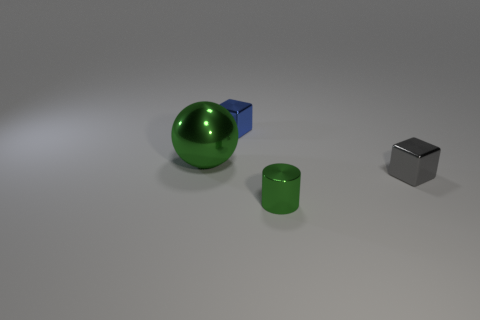Add 3 balls. How many objects exist? 7 Subtract all cylinders. How many objects are left? 3 Add 2 gray cubes. How many gray cubes exist? 3 Subtract 0 yellow spheres. How many objects are left? 4 Subtract all small purple cylinders. Subtract all small things. How many objects are left? 1 Add 3 gray metallic objects. How many gray metallic objects are left? 4 